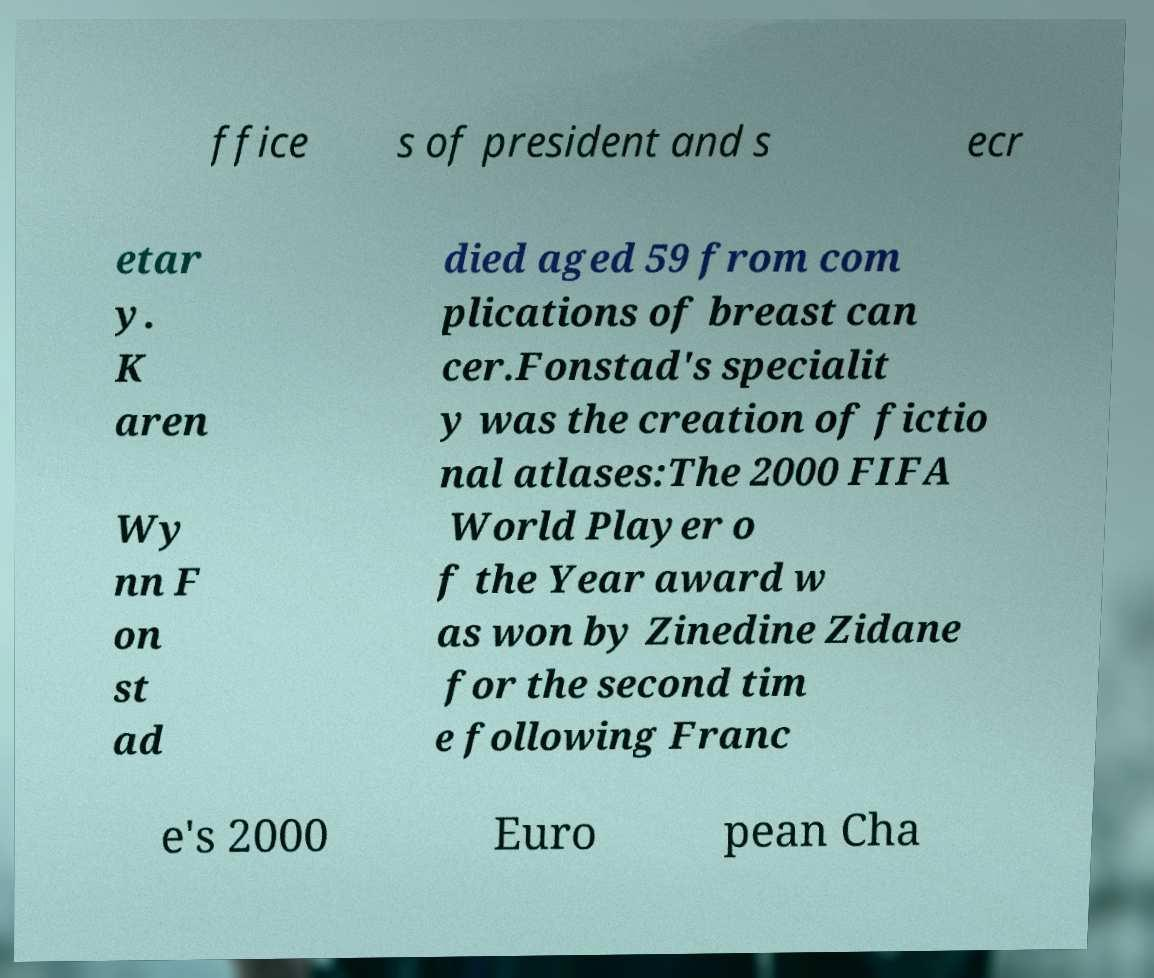Please identify and transcribe the text found in this image. ffice s of president and s ecr etar y. K aren Wy nn F on st ad died aged 59 from com plications of breast can cer.Fonstad's specialit y was the creation of fictio nal atlases:The 2000 FIFA World Player o f the Year award w as won by Zinedine Zidane for the second tim e following Franc e's 2000 Euro pean Cha 